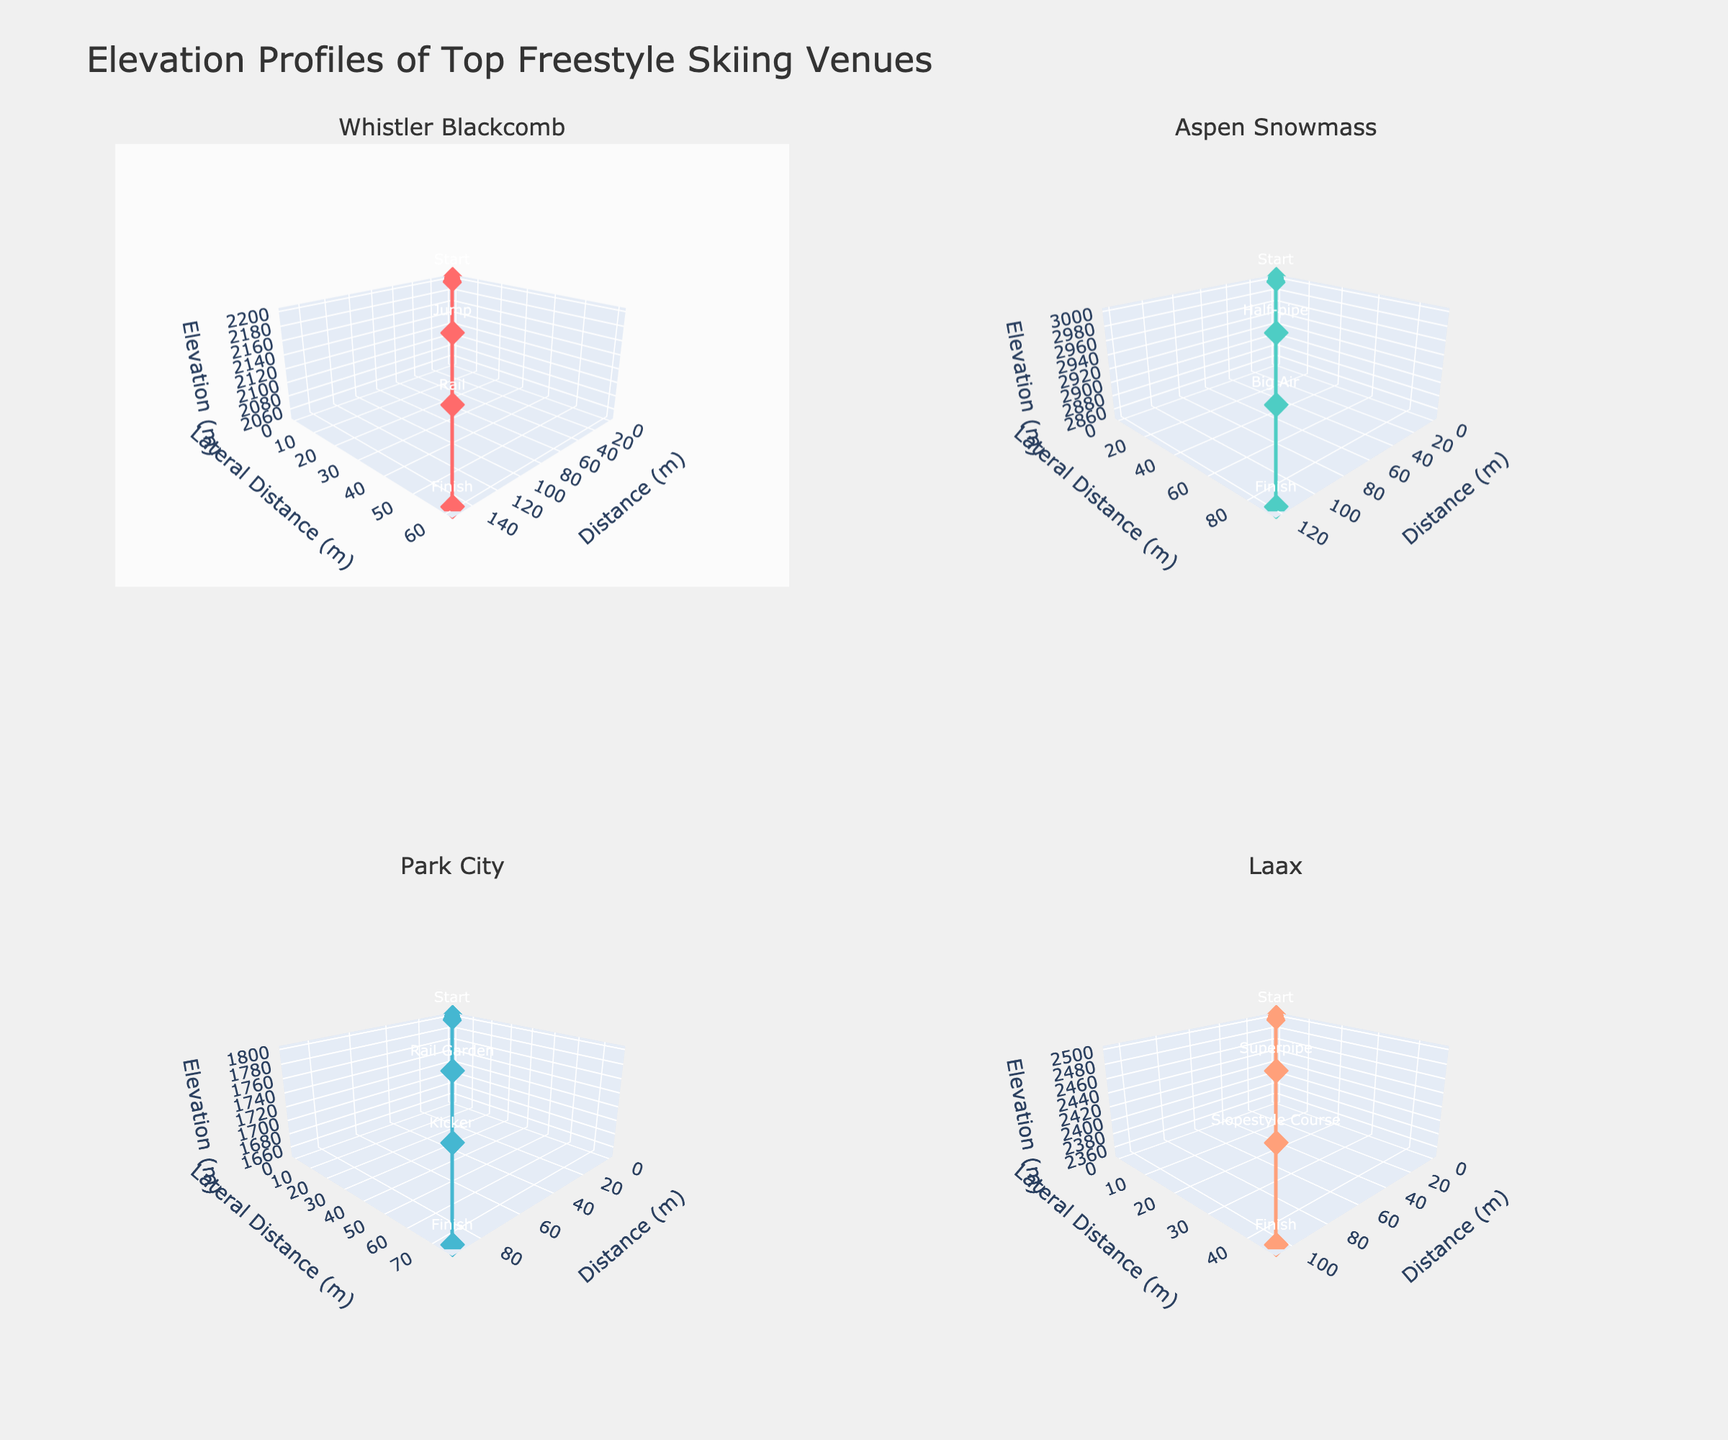How many freestyle skiing venues are shown in the figure? The figure's subplot titles list four different venues, indicating the number of venues visualized.
Answer: 4 What is the highest starting elevation among all venues? By looking at the Z-axis values at the "Start" points, Aspen Snowmass has the highest starting elevation at 3000 meters.
Answer: 3000 meters Which venue has the lowest finishing elevation? Looking at the Z-axis values at the "Finish" points, Park City has the lowest finishing elevation at 1650 meters.
Answer: 1650 meters What terrain features can be found in Whistler Blackcomb? By observing the text annotations for Whistler Blackcomb, the features are Start, Jump, Rail, and Finish.
Answer: Start, Jump, Rail, Finish How does the slope angle between Start and Finish in Laax compare to that in Park City? Slope angle can be understood by the relative steepness of the lines. Laax has a less steep (more gradual) descent compared to Park City's sharper decline based on the Z-axis values over distance.
Answer: Laax has a more gradual slope Which venue has the longest horizontal distance mapped? By looking at the X-axis values, Aspen Snowmass has the longest horizontal distance as it spans from 0 to 120 meters.
Answer: Aspen Snowmass If you were to compare the 'Big Air' feature in Aspen Snowmass to the 'Superpipe' feature in Laax, which is at a higher elevation? 'Big Air' in Aspen Snowmass is at 2900 meters while 'Superpipe' in Laax is at 2450 meters.
Answer: Big Air How does the lateral distance (Y-axis) of the 'Rail' feature in Park City compare to the 'Half-pipe' feature in Aspen Snowmass? The lateral distance (Y-axis) for 'Rail' in Park City is 25 meters, while it is 30 meters for the 'Half-pipe' in Aspen Snowmass.
Answer: Half-pipe is higher Which two venues have similar elevation profiles from start to finish? By visually inspecting the lines and elevation changes, Whistler Blackcomb and Laax both show a steady descent from high to lower elevations in a similar pattern.
Answer: Whistler Blackcomb and Laax What is the vertical drop from Start to Finish in Whistler Blackcomb? The starting elevation at Whistler Blackcomb is 2200 meters and the finishing elevation is 2050 meters. The vertical drop is 2200 - 2050 = 150 meters.
Answer: 150 meters 